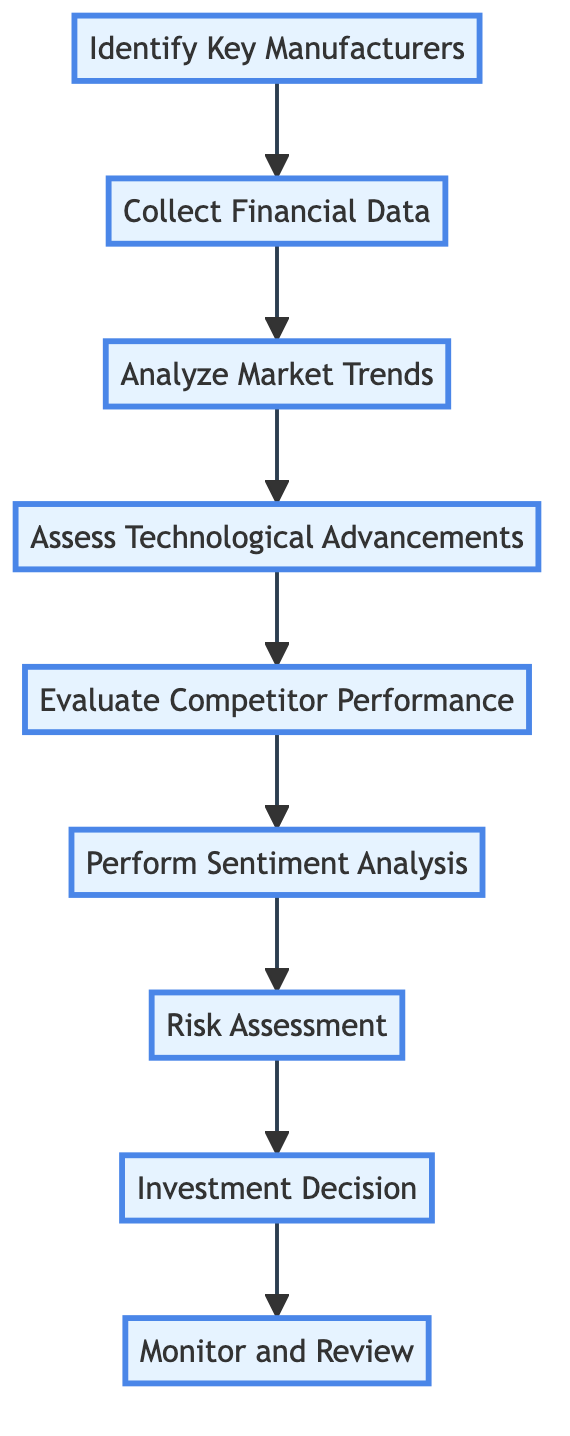What is the final step in the process? The diagram shows a sequence of steps leading to the final action taken in the process. By tracing the arrows from the last node, we see that "Monitor and Review" is the ending step.
Answer: Monitor and Review How many total steps are there in the evaluation process? The diagram lists each step in the flowchart which can be counted. There are nine distinct steps from identifying manufacturers to monitoring performance.
Answer: Nine What is the first action to take in this sequence? The first node in the flowchart indicates the starting point of the evaluation, which is "Identify Key Manufacturers."
Answer: Identify Key Manufacturers Which step comes after "Assess Technological Advancements"? The structure of the diagram allows us to follow the arrows from "Assess Technological Advancements." The next step indicated is "Evaluate Competitor Performance."
Answer: Evaluate Competitor Performance What kind of analysis is performed after competitor performance is evaluated? By following the flow from the "Evaluate Competitor Performance" step, the next action in the sequence is to "Perform Sentiment Analysis."
Answer: Perform Sentiment Analysis What is the main focus of the "Risk Assessment" step? The title of the "Risk Assessment" step denotes evaluating potential risks. Exploring related steps indicates that this is where one considers supply chain issues, regulatory hurdles, and economic downturns.
Answer: Supply chain issues, regulatory hurdles, and economic downturns How does the "Collect Financial Data" step relate to the "Analyze Market Trends" step? The flowchart connects these two steps sequentially, implying that collecting financial data feeds into the analysis of market trends for further evaluation.
Answer: Sequentially connected Which step provides the basis for making investment decisions? Examining the preceding steps in the flowchart, it's clear that the data and analyses from previous steps culminate in the "Investment Decision," which is directly influenced by the collected information.
Answer: Investment Decision What type of data is collected in the "Collect Financial Data" step? The description for "Collect Financial Data" specifies historical and current financial data, which includes stock prices, P/E ratios, and earnings reports.
Answer: Historical and current financial data, stock prices, P/E ratios, earnings reports 